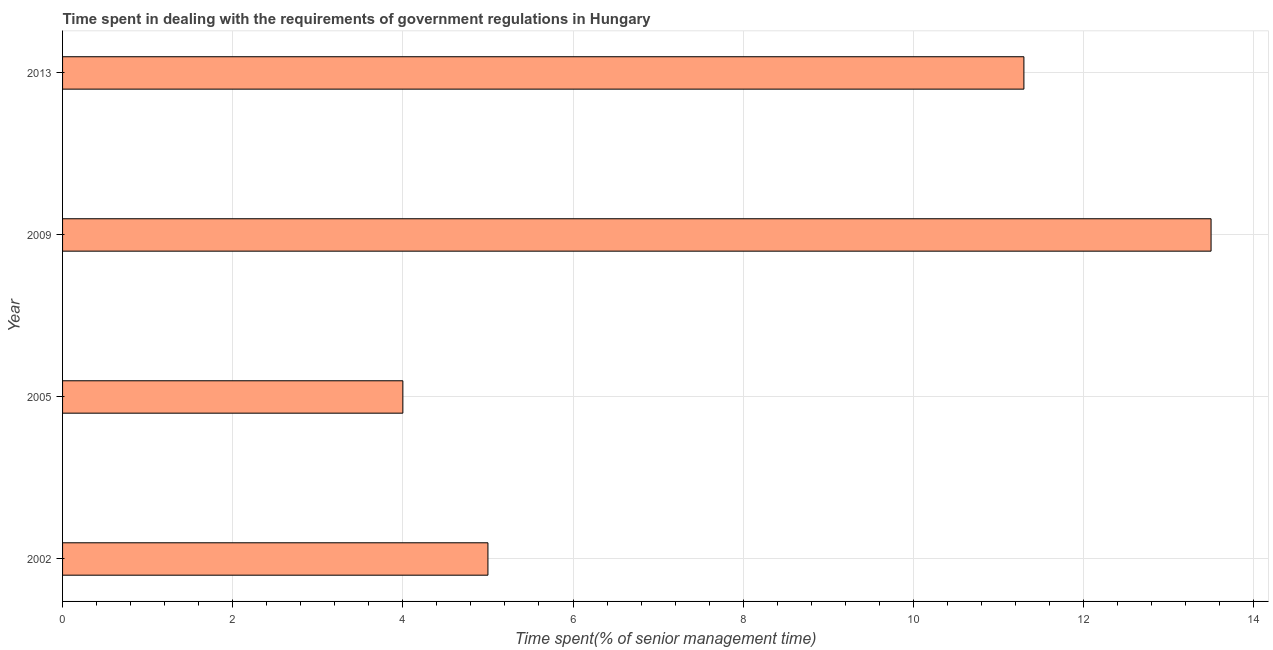Does the graph contain any zero values?
Offer a terse response. No. Does the graph contain grids?
Offer a terse response. Yes. What is the title of the graph?
Your answer should be very brief. Time spent in dealing with the requirements of government regulations in Hungary. What is the label or title of the X-axis?
Offer a very short reply. Time spent(% of senior management time). What is the label or title of the Y-axis?
Give a very brief answer. Year. What is the time spent in dealing with government regulations in 2009?
Offer a terse response. 13.5. Across all years, what is the maximum time spent in dealing with government regulations?
Ensure brevity in your answer.  13.5. In which year was the time spent in dealing with government regulations maximum?
Provide a short and direct response. 2009. What is the sum of the time spent in dealing with government regulations?
Offer a terse response. 33.8. What is the difference between the time spent in dealing with government regulations in 2002 and 2013?
Your answer should be compact. -6.3. What is the average time spent in dealing with government regulations per year?
Your answer should be compact. 8.45. What is the median time spent in dealing with government regulations?
Your answer should be very brief. 8.15. What is the ratio of the time spent in dealing with government regulations in 2005 to that in 2009?
Your answer should be very brief. 0.3. Is the time spent in dealing with government regulations in 2002 less than that in 2009?
Your answer should be compact. Yes. What is the difference between the highest and the second highest time spent in dealing with government regulations?
Keep it short and to the point. 2.2. What is the difference between the highest and the lowest time spent in dealing with government regulations?
Provide a succinct answer. 9.5. How many bars are there?
Offer a terse response. 4. How many years are there in the graph?
Offer a terse response. 4. What is the difference between two consecutive major ticks on the X-axis?
Your answer should be very brief. 2. Are the values on the major ticks of X-axis written in scientific E-notation?
Provide a succinct answer. No. What is the Time spent(% of senior management time) of 2005?
Offer a terse response. 4. What is the Time spent(% of senior management time) in 2009?
Keep it short and to the point. 13.5. What is the difference between the Time spent(% of senior management time) in 2002 and 2009?
Offer a terse response. -8.5. What is the difference between the Time spent(% of senior management time) in 2002 and 2013?
Offer a terse response. -6.3. What is the difference between the Time spent(% of senior management time) in 2005 and 2009?
Offer a very short reply. -9.5. What is the difference between the Time spent(% of senior management time) in 2005 and 2013?
Your response must be concise. -7.3. What is the ratio of the Time spent(% of senior management time) in 2002 to that in 2005?
Your response must be concise. 1.25. What is the ratio of the Time spent(% of senior management time) in 2002 to that in 2009?
Your answer should be compact. 0.37. What is the ratio of the Time spent(% of senior management time) in 2002 to that in 2013?
Make the answer very short. 0.44. What is the ratio of the Time spent(% of senior management time) in 2005 to that in 2009?
Offer a terse response. 0.3. What is the ratio of the Time spent(% of senior management time) in 2005 to that in 2013?
Give a very brief answer. 0.35. What is the ratio of the Time spent(% of senior management time) in 2009 to that in 2013?
Keep it short and to the point. 1.2. 